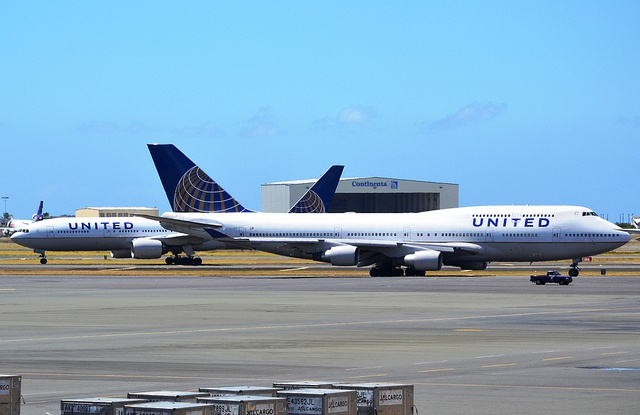Describe the objects in this image and their specific colors. I can see airplane in lightblue, white, black, navy, and gray tones, airplane in lightblue, black, white, and gray tones, truck in lightblue, black, gray, and navy tones, and airplane in lightblue, white, darkgray, gray, and black tones in this image. 